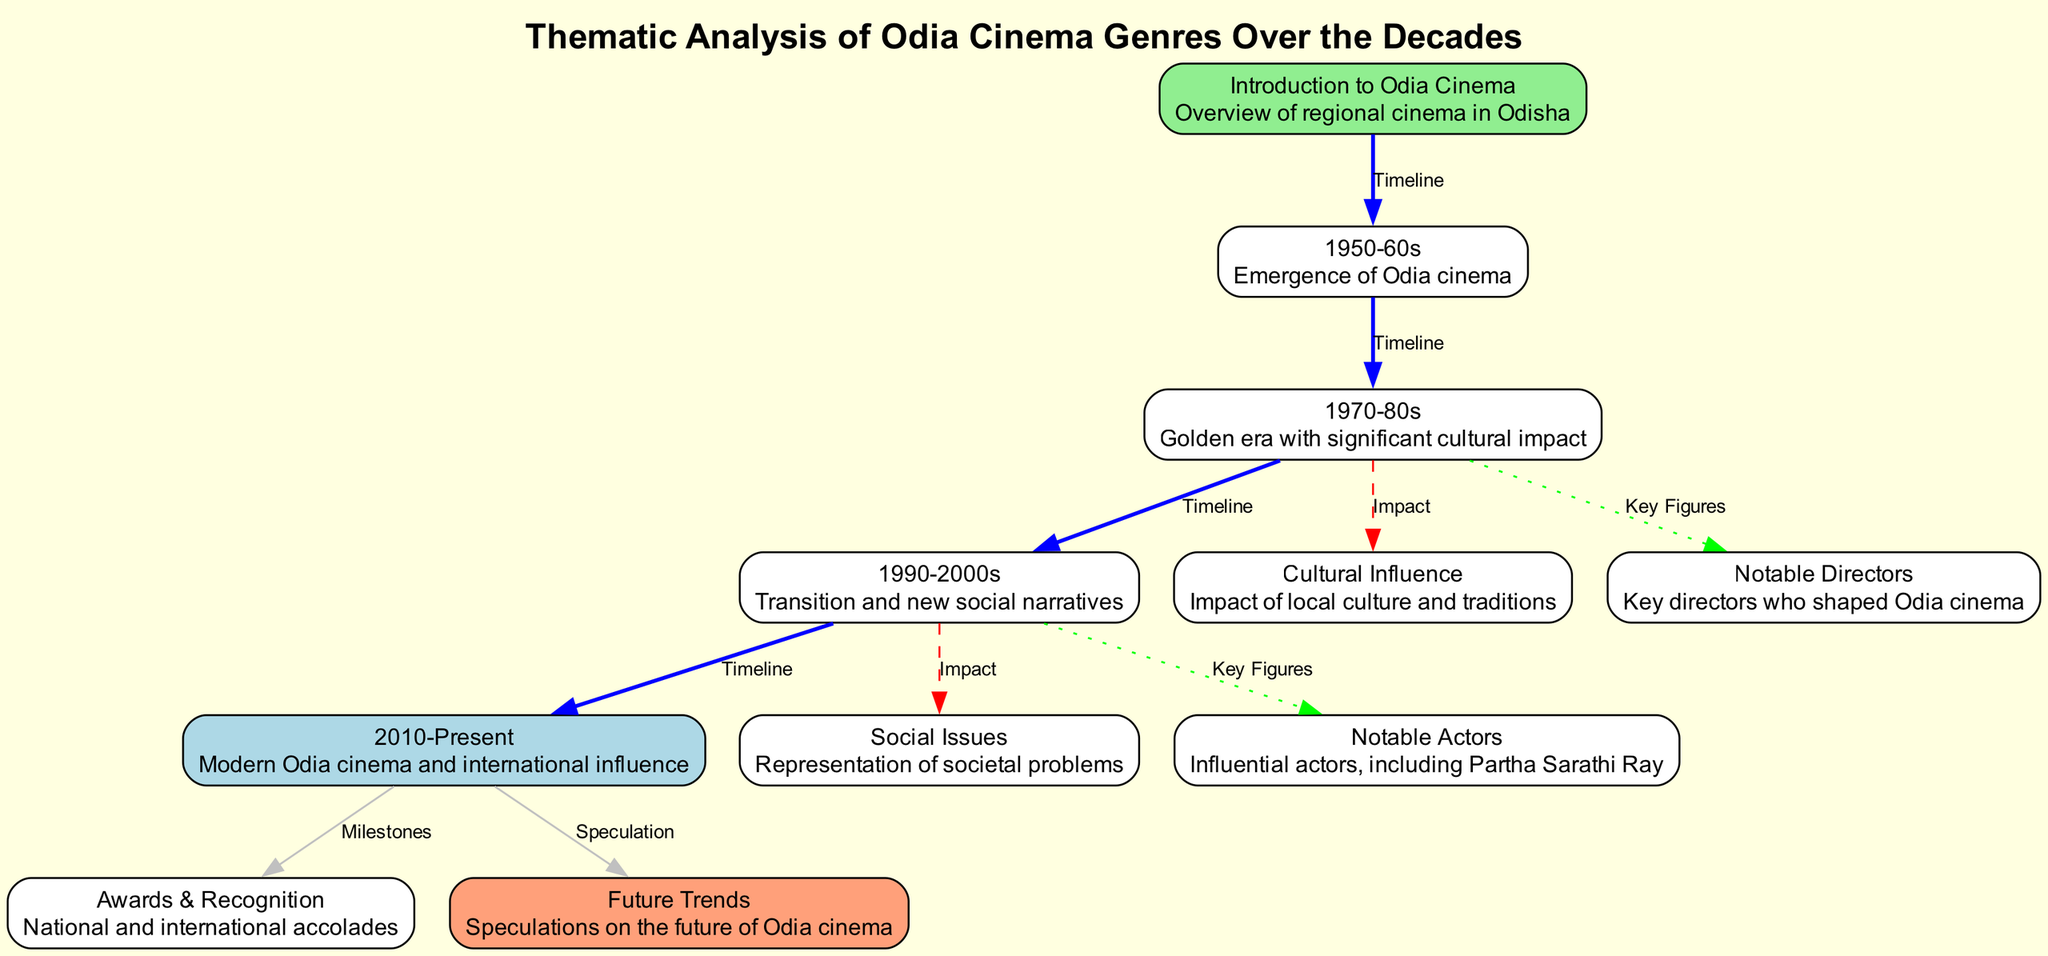What is the starting node in the diagram? The starting node is labeled "Introduction to Odia Cinema" and provides an overview of regional cinema in Odisha. This is clearly identified as the entry point of the diagram.
Answer: Introduction to Odia Cinema How many decades are represented in the diagram? The diagram shows five distinct decades, specifically: 1950-60s, 1970-80s, 1990-2000s, and 2010-present. By counting each decade displayed, we identify the total number of decades represented.
Answer: Four Which node is linked to "1970-80s" as a cultural influence? The node "Cultural Influence" is linked to "1970-80s" indicating its significant impact during that era. The edge connecting them is labeled "Impact," which denotes a direct relationship between the cultural influence and the 1970-80s period.
Answer: Cultural Influence What milestone is highlighted in the "2010-Present" node? The "Awards & Recognition" node is connected to "2010-Present," showcasing milestones such as national and international accolades garnered by modern Odia cinema. This connection indicates the achievements of Odia cinema during the contemporary era.
Answer: Awards & Recognition Which two nodes are connected by a dashed line, indicating an impact relationship? The nodes "1990-2000s" and "social issues" are connected by a dashed line that signifies the representation of societal problems during that period. The type of line used indicates the nature of their relationship as one impacting the other.
Answer: social issues Which notable figures are associated with the "1970-80s" node? The "Notable Directors" node is linked to the "1970-80s" node by a dotted line, signifying key figures in Odia cinema who were prominent during that decade. This shows the connection and influence these directors had during the golden era of Odia cinema.
Answer: Notable Directors What node follows the "1990-2000s" node in the timeline sequence? The node that follows "1990-2000s" in the timeline is "2010-Present." This is specified by the edge labeled "Timeline" that connects these two nodes, illustrating the chronological flow of Odia cinema.
Answer: 2010-Present What is speculated about future trends in the "2010-Present" node? The "Future Trends" node is connected to "2010-Present," which suggests that discussions about the future of Odia cinema are anticipated based on developments in the modern era. This connection indicates ongoing speculation regarding future directions.
Answer: Future Trends How does the diagram depict the relationship between the "1970-80s" and "notable directors"? The diagram represents this relationship through a dotted line connecting "1970-80s" to "Notable Directors," indicating that this period was critical for establishing key figures in Odia cinema. This visual representation underscores the importance of directors during the golden era.
Answer: Notable Directors 